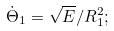<formula> <loc_0><loc_0><loc_500><loc_500>\dot { \Theta } _ { 1 } = \sqrt { E } / R _ { 1 } ^ { 2 } ;</formula> 